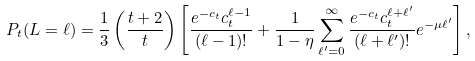<formula> <loc_0><loc_0><loc_500><loc_500>P _ { t } ( L = \ell ) = \frac { 1 } { 3 } \left ( \frac { t + 2 } { t } \right ) \left [ \frac { e ^ { - c _ { t } } c _ { t } ^ { \ell - 1 } } { ( \ell - 1 ) ! } + \frac { 1 } { 1 - \eta } \sum _ { \ell ^ { \prime } = 0 } ^ { \infty } \frac { e ^ { - c _ { t } } c _ { t } ^ { \ell + \ell ^ { \prime } } } { ( \ell + \ell ^ { \prime } ) ! } e ^ { - \mu \ell ^ { \prime } } \right ] ,</formula> 